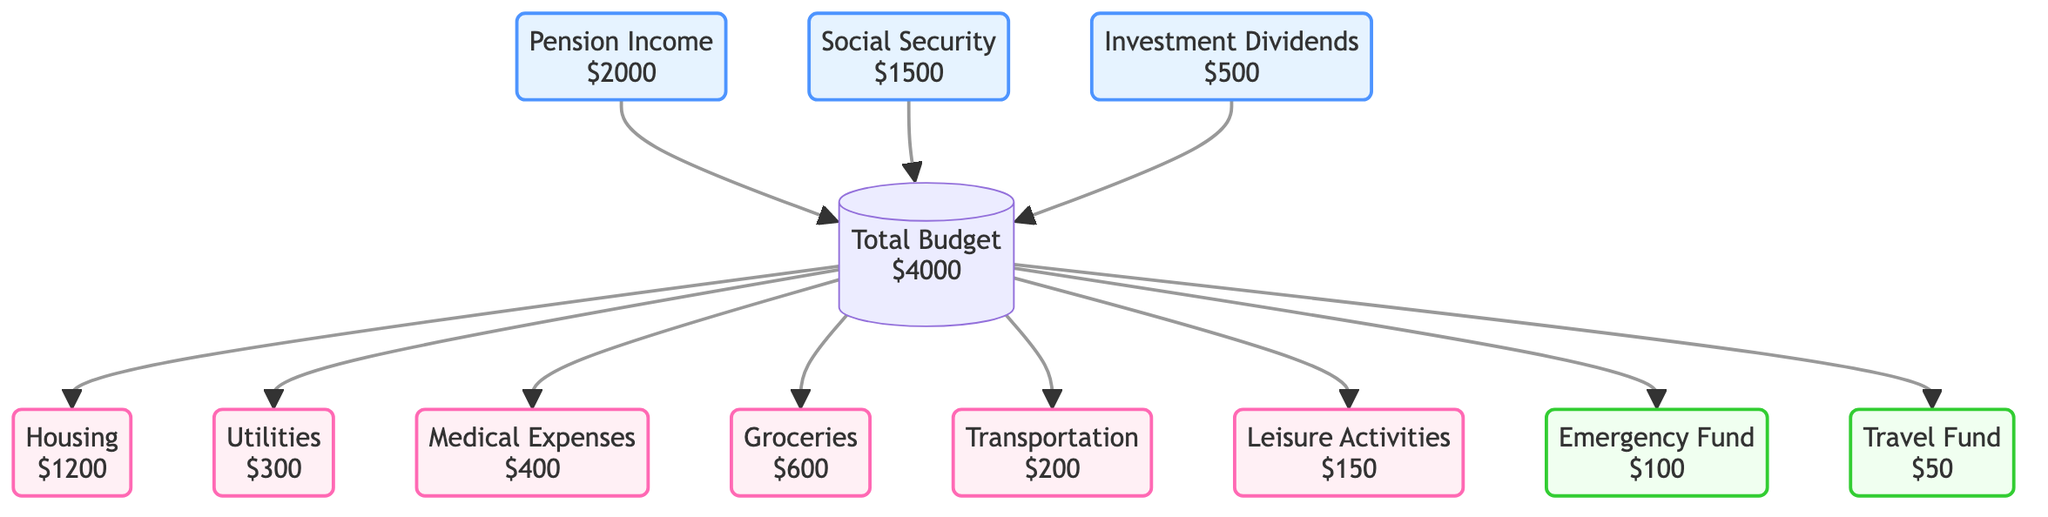What is the total income from pension? The diagram specifies the "Pension Income" node with a value of $2000. It represents one of the income sources listed, so the answer is directly taken from that node.
Answer: 2000 What is the total amount allocated for medical expenses? In the diagram, "Medical Expenses" is shown as a node and carries an amount of $400. This is the direct value represented in that expense category.
Answer: 400 How many sources of income are listed in the diagram? There are three distinct nodes representing income sources: Pension Income, Social Security Benefits, and Investment Dividends. Thus, the count is derived from simply counting those nodes.
Answer: 3 What is the total amount for all leisure activities? The "Leisure Activities" node in the diagram indicates an amount of $150 allocated for that expense. The amount is found directly on that specific expense node.
Answer: 150 What is the total budget displayed in the diagram? The "Total Budget" node shows a value of $4000 at the start, which aggregates all income sources before expenses and savings are deducted. The answer is taken from the identifying node itself.
Answer: 4000 What are the total savings goals as per the diagram? The diagram specifies two savings goals: "Emergency Fund" ($100) and "Travel Fund" ($50). The total savings goals can be calculated by summing these two values: 100 + 50 = 150.
Answer: 150 What is the total amount allocated for housing? The "Housing" node in the diagram lists an expense of $1200. This is the specific amount tied to that expense category.
Answer: 1200 Which income source has the lowest amount? Among the income sources presented, "Investment Dividends" is listed with the lowest value of $500. A comparison of all income nodes directly shows this.
Answer: Investment Dividends Which expense category has the highest cost? By reviewing the expense nodes, the "Housing" category shows the highest amount of $1200. No other expense node has a higher value, making this the answer derived from the comparison of nodes.
Answer: Housing 